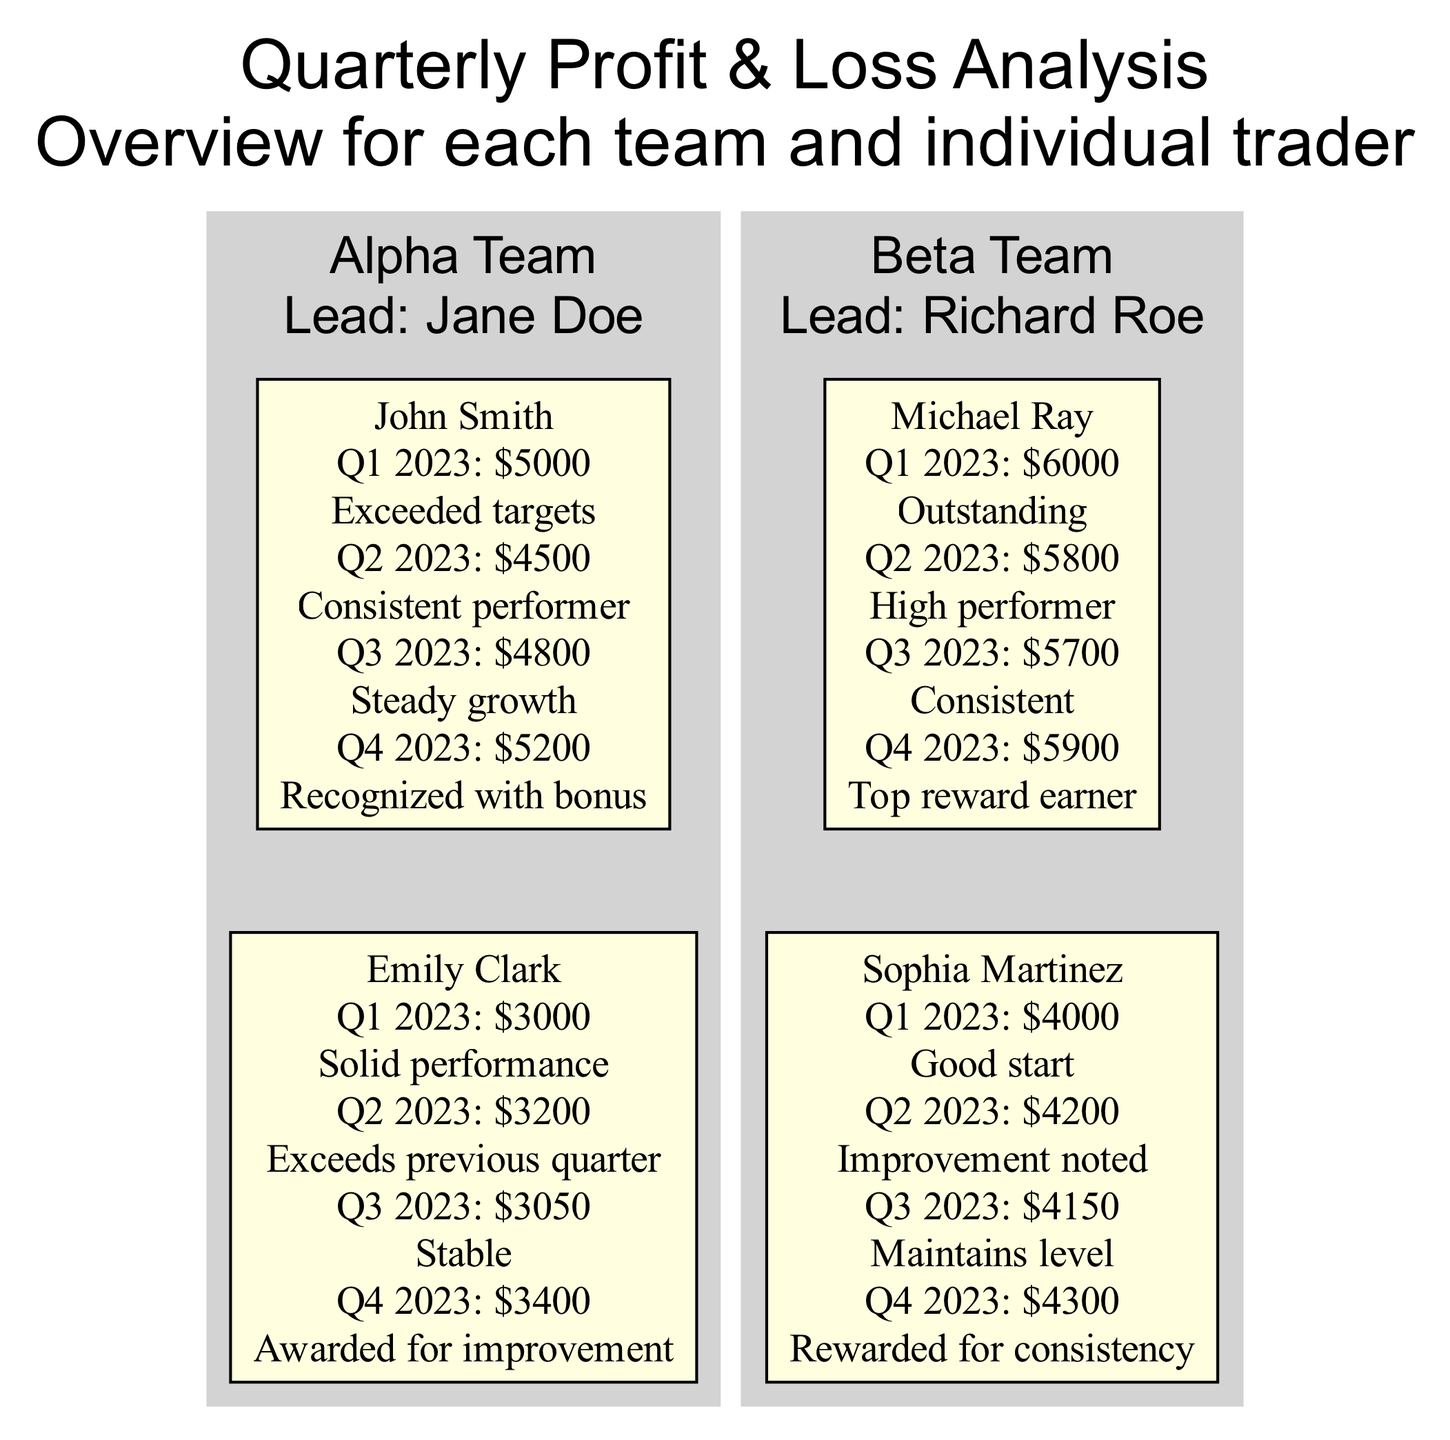What was John Smith's profit in Q4 2023? Looking at the diagram for John Smith under the Alpha Team, his profit for Q4 2023 is clearly stated as 5200.
Answer: 5200 Which team did Sophia Martinez belong to? By checking the information in the Beta Team section of the diagram, it identifies Sophia Martinez as one of the traders under the Beta Team.
Answer: Beta Team How many traders are in the Alpha Team? In the Alpha Team section of the diagram, there are two traders listed: John Smith and Emily Clark. Therefore, the total number is 2.
Answer: 2 What annotation is made for Michael Ray's performance in Q1 2023? In the Beta Team section, looking at Michael Ray's Q1 2023 performance, the annotation is listed as "Outstanding."
Answer: Outstanding Which trader received a bonus in Q4 2023? The diagram indicates that John Smith received a recognition bonus in Q4 2023.
Answer: John Smith What was the total profit of Sophia Martinez over the four quarters? By summing up Sophia Martinez's profits from each quarter: 4000 + 4200 + 4150 + 4300, the total comes out to 16650.
Answer: 16650 Who was the leader of the Beta Team? The Beta Team section identifies Richard Roe as the leader of the Beta Team.
Answer: Richard Roe Which quarter showed the highest profit for Michael Ray? The diagram indicates that Michael Ray's highest profit was in Q1 2023, with a profit of 6000.
Answer: Q1 2023 What performance annotation is common for both Sophia Martinez and John Smith in Q4 2023? The diagram shows that both Sophia Martinez and John Smith received rewards for their performances in Q4 2023, as Sophia was recognized for "consistency" and John for his "bonus."
Answer: Rewarded 